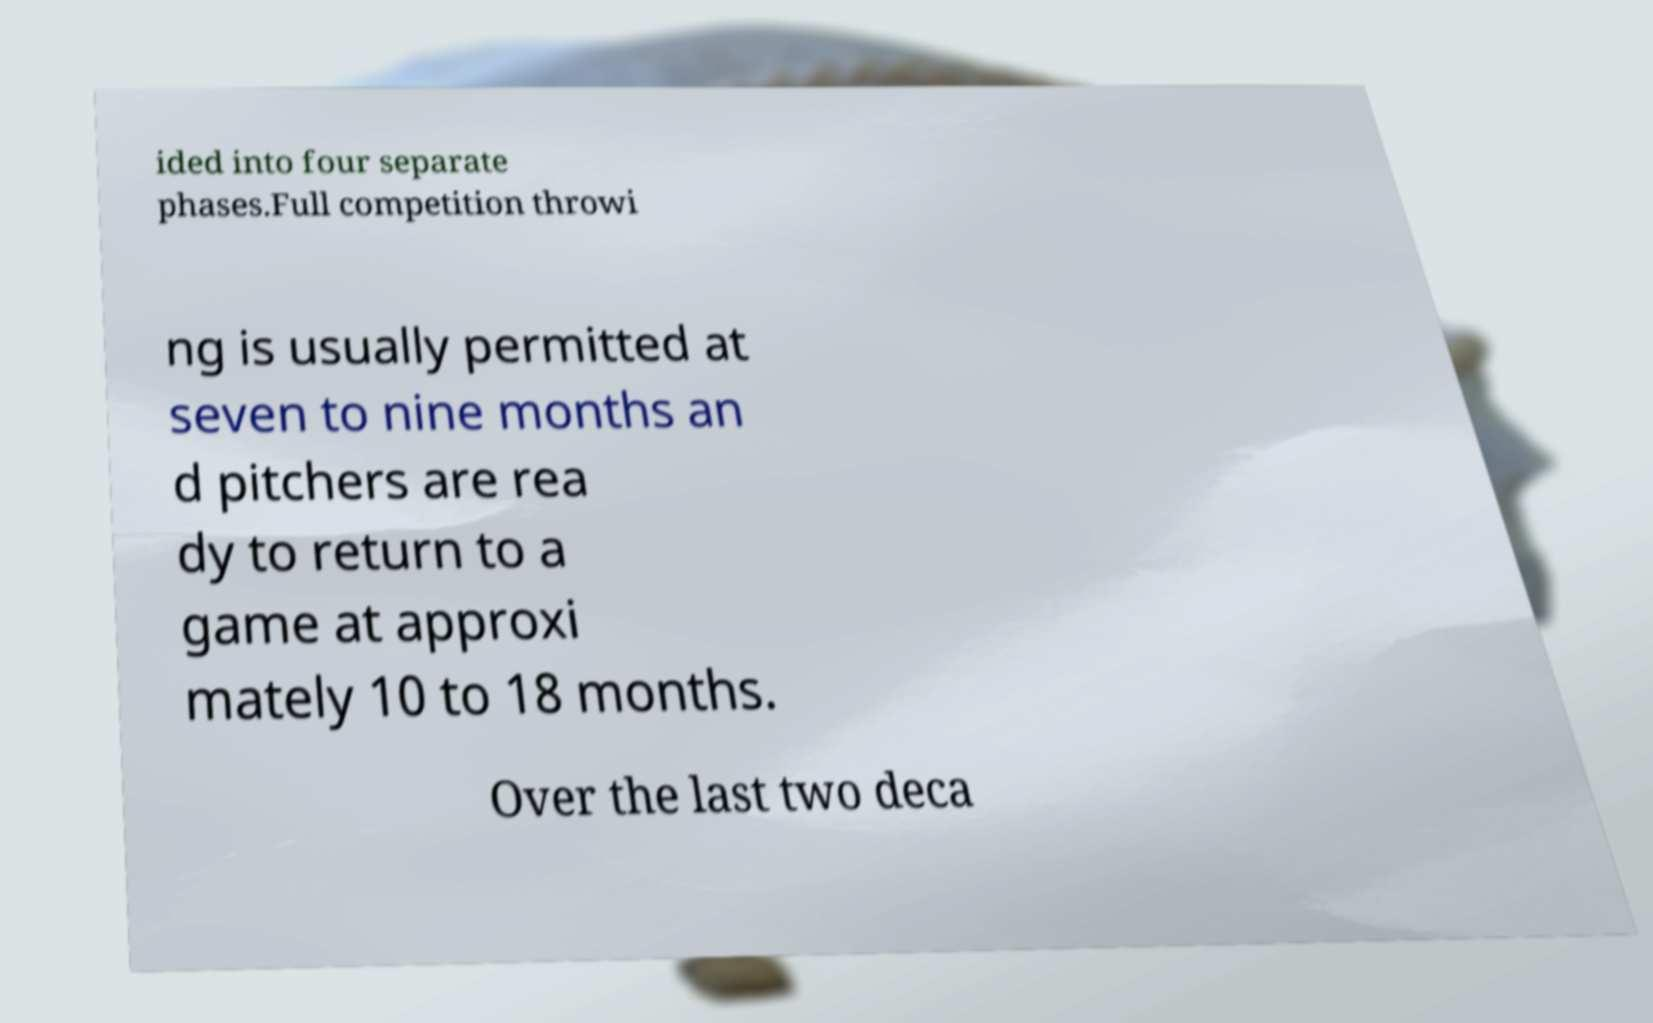Could you extract and type out the text from this image? ided into four separate phases.Full competition throwi ng is usually permitted at seven to nine months an d pitchers are rea dy to return to a game at approxi mately 10 to 18 months. Over the last two deca 